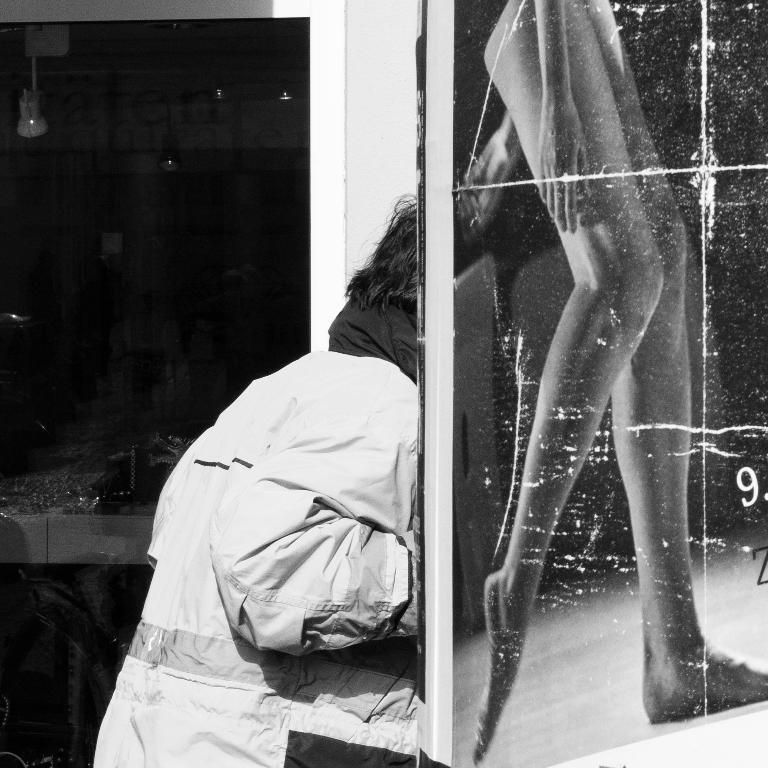Could you give a brief overview of what you see in this image? In the middle a person is there, this person wore coat. On the right side there is an image of the legs of a human. It is in black and white color. 